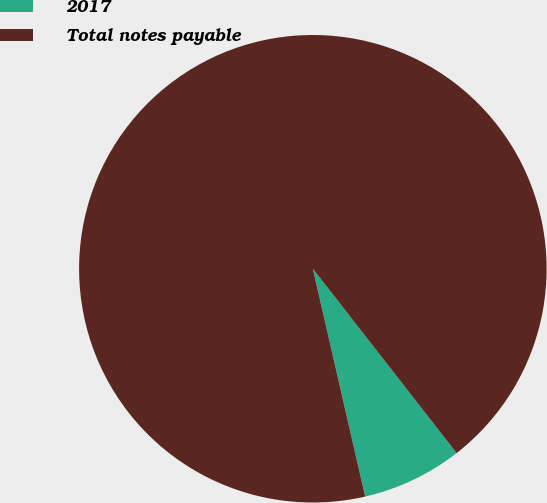Convert chart to OTSL. <chart><loc_0><loc_0><loc_500><loc_500><pie_chart><fcel>2017<fcel>Total notes payable<nl><fcel>6.95%<fcel>93.05%<nl></chart> 